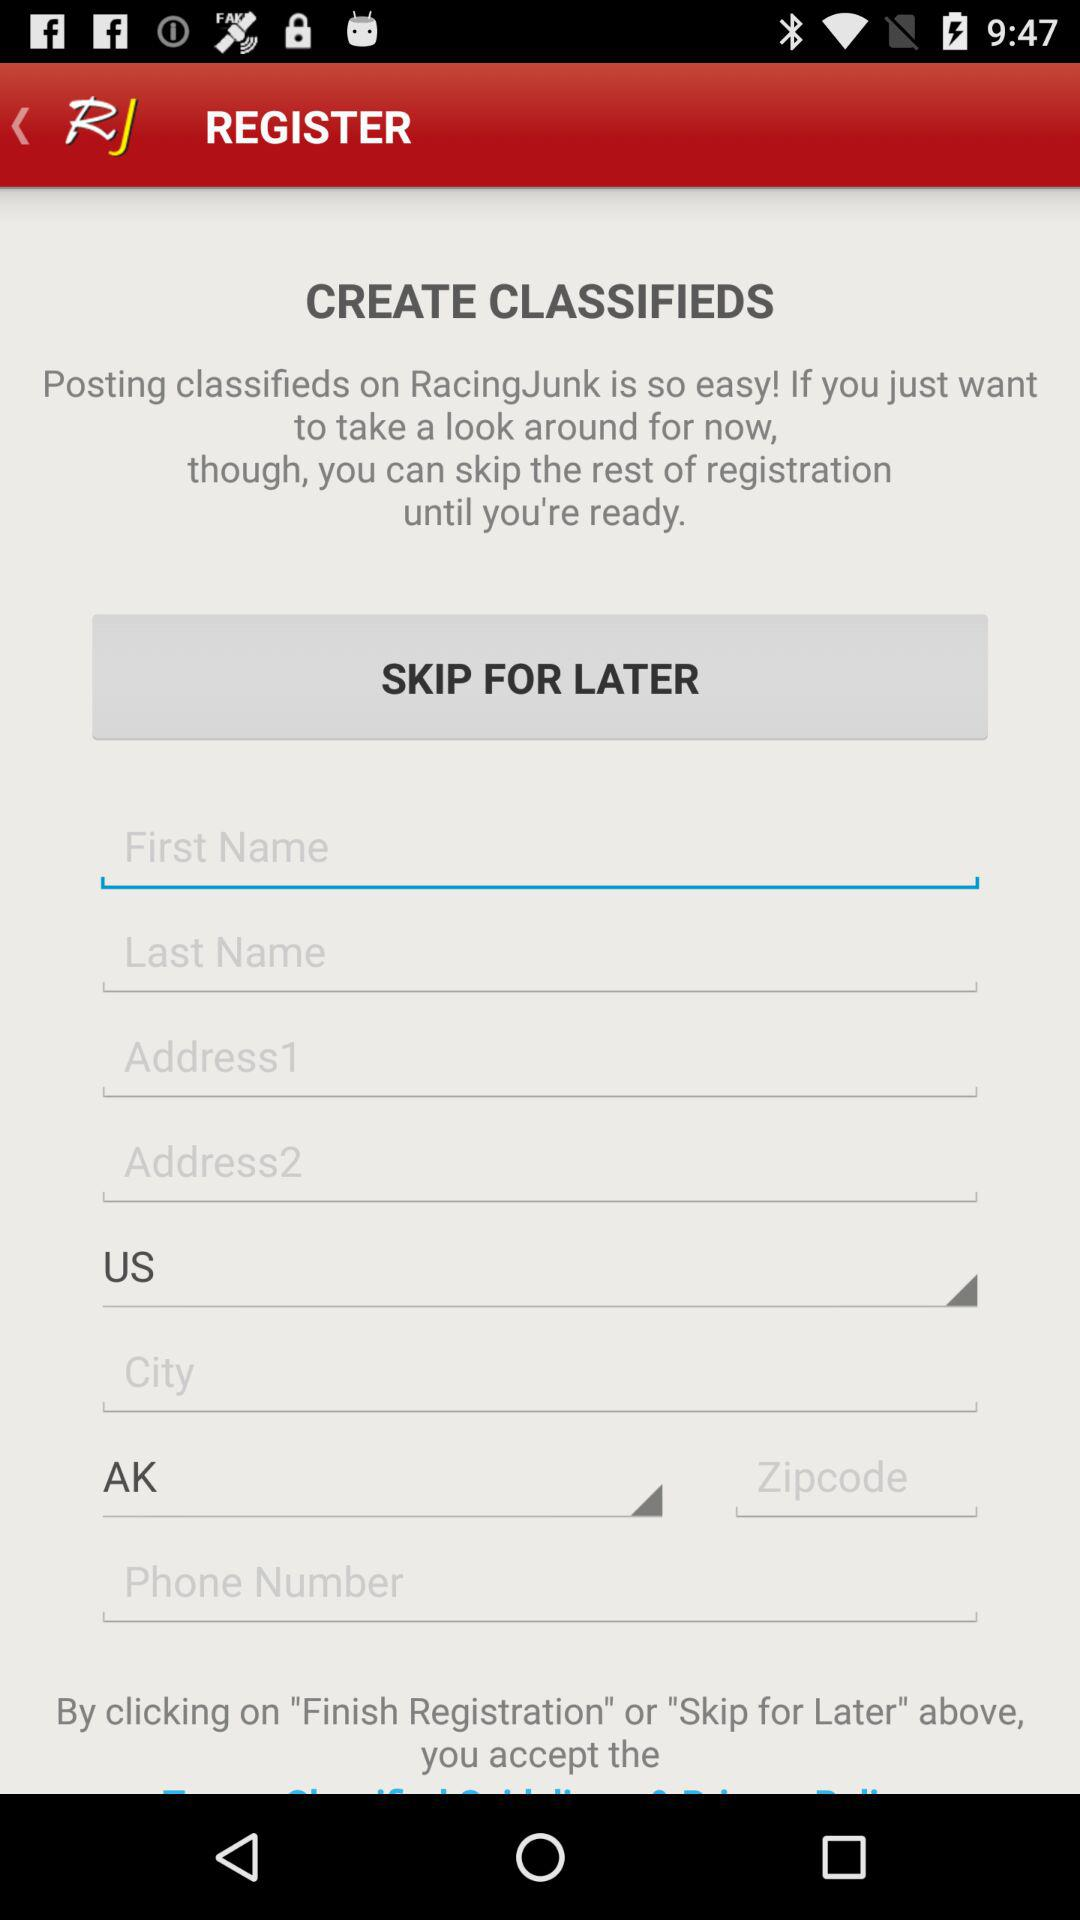What is the country? The country is US. 